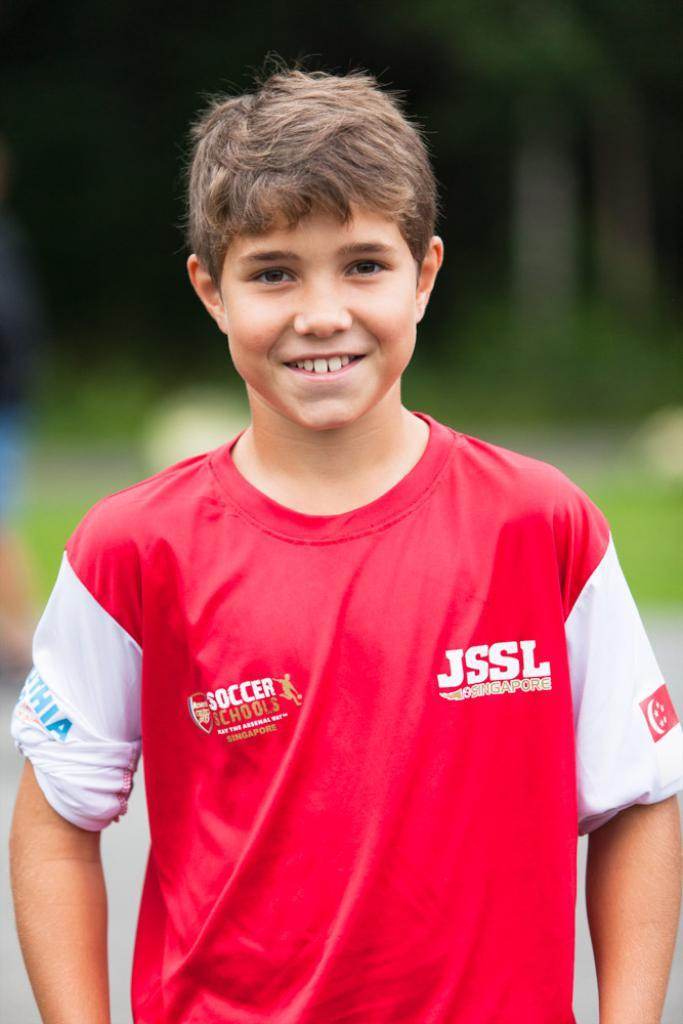Provide a one-sentence caption for the provided image. A boy smiles for the camera and is wearing a soccer jersey. 